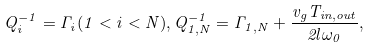<formula> <loc_0><loc_0><loc_500><loc_500>Q _ { i } ^ { - 1 } = \Gamma _ { i } ( 1 < i < N ) , Q _ { 1 , N } ^ { - 1 } = \Gamma _ { 1 , N } + \frac { v _ { g } T _ { i n , o u t } } { 2 l \omega _ { 0 } } ,</formula> 